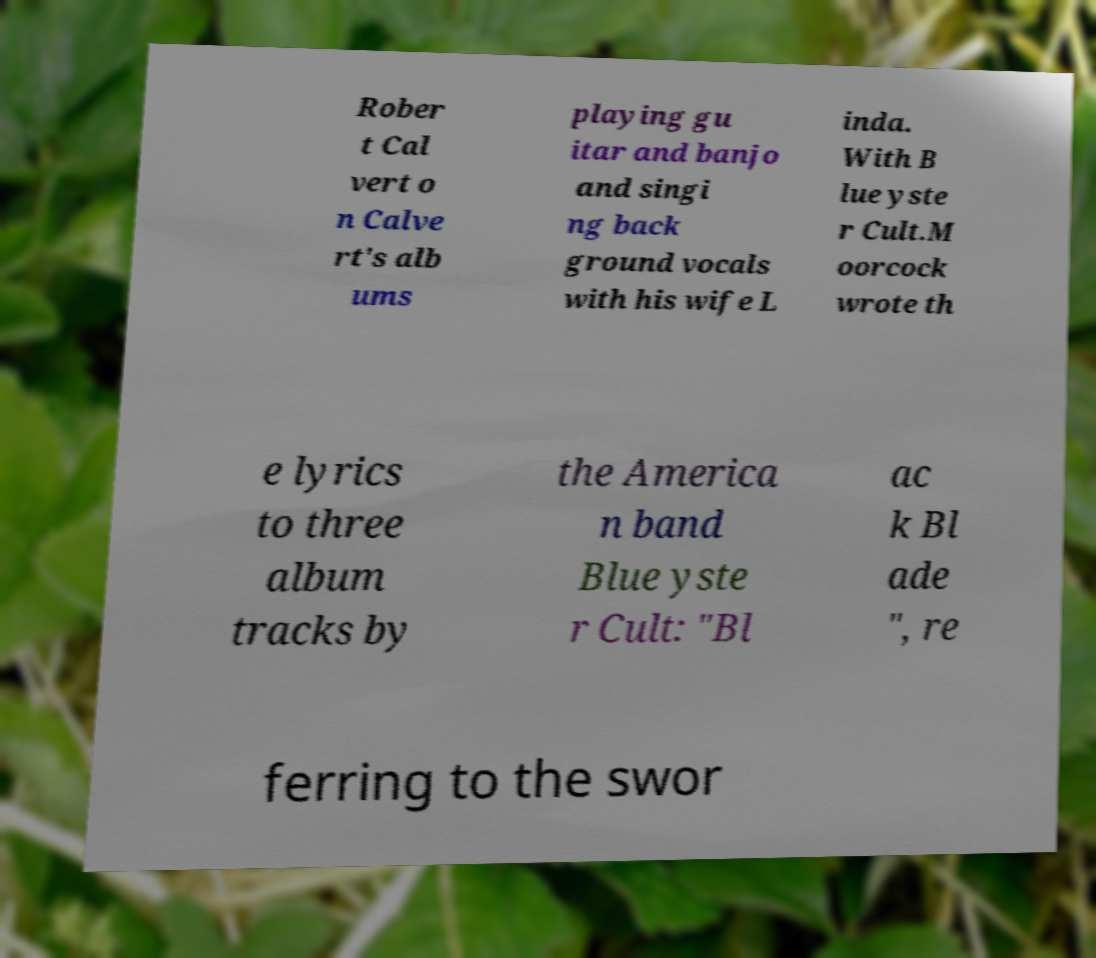There's text embedded in this image that I need extracted. Can you transcribe it verbatim? Rober t Cal vert o n Calve rt's alb ums playing gu itar and banjo and singi ng back ground vocals with his wife L inda. With B lue yste r Cult.M oorcock wrote th e lyrics to three album tracks by the America n band Blue yste r Cult: "Bl ac k Bl ade ", re ferring to the swor 